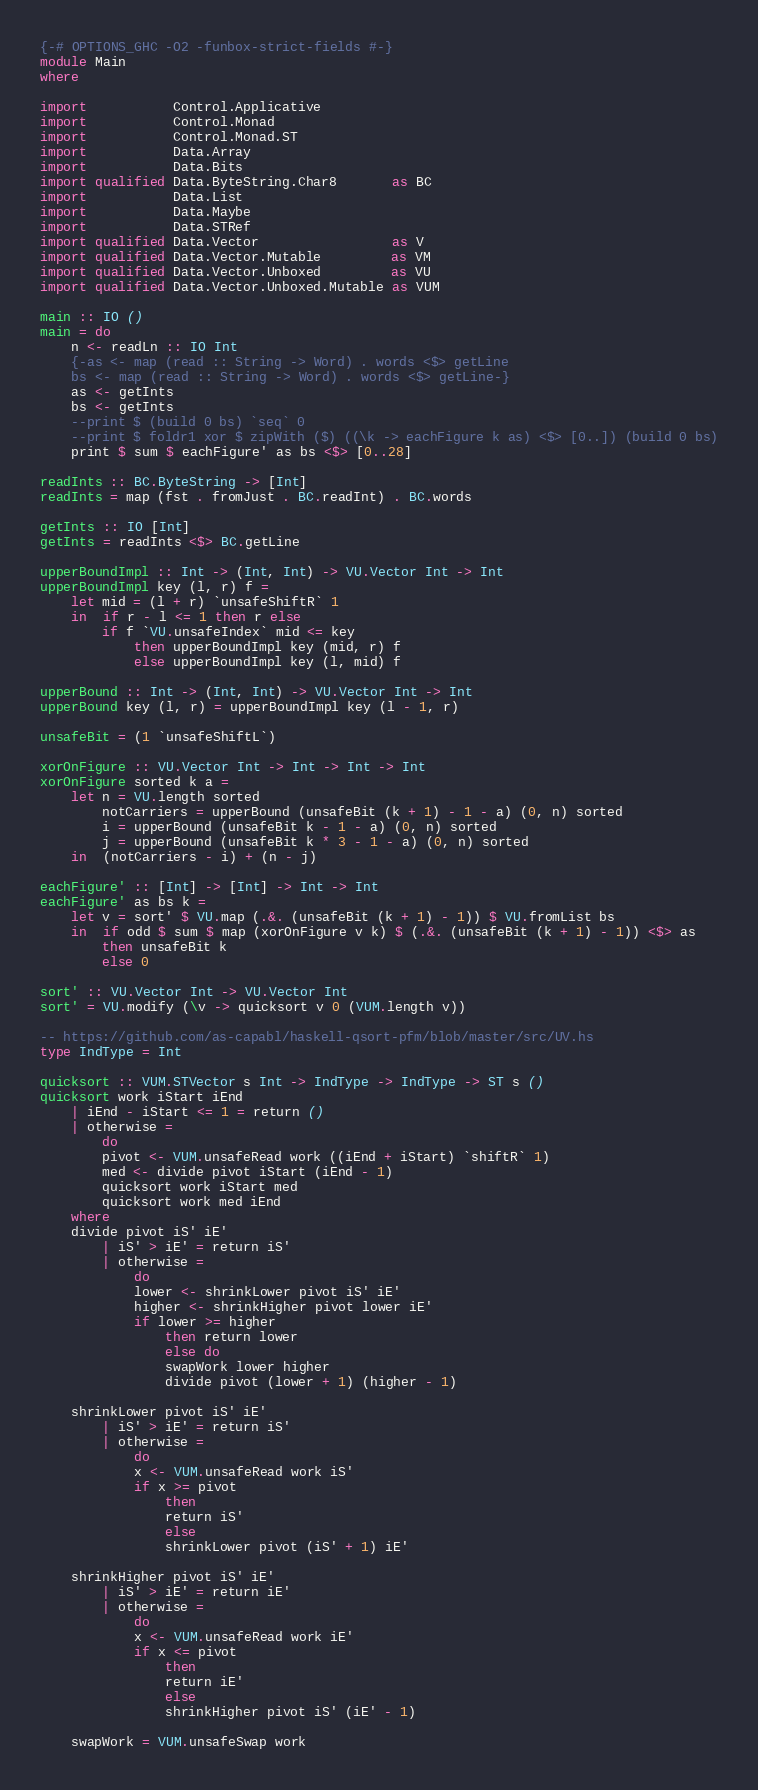<code> <loc_0><loc_0><loc_500><loc_500><_Haskell_>{-# OPTIONS_GHC -O2 -funbox-strict-fields #-}
module Main
where

import           Control.Applicative
import           Control.Monad
import           Control.Monad.ST
import           Data.Array
import           Data.Bits
import qualified Data.ByteString.Char8       as BC
import           Data.List
import           Data.Maybe
import           Data.STRef
import qualified Data.Vector                 as V
import qualified Data.Vector.Mutable         as VM
import qualified Data.Vector.Unboxed         as VU
import qualified Data.Vector.Unboxed.Mutable as VUM

main :: IO ()
main = do
    n <- readLn :: IO Int
    {-as <- map (read :: String -> Word) . words <$> getLine
    bs <- map (read :: String -> Word) . words <$> getLine-}
    as <- getInts
    bs <- getInts
    --print $ (build 0 bs) `seq` 0
    --print $ foldr1 xor $ zipWith ($) ((\k -> eachFigure k as) <$> [0..]) (build 0 bs)
    print $ sum $ eachFigure' as bs <$> [0..28]

readInts :: BC.ByteString -> [Int]
readInts = map (fst . fromJust . BC.readInt) . BC.words

getInts :: IO [Int]
getInts = readInts <$> BC.getLine

upperBoundImpl :: Int -> (Int, Int) -> VU.Vector Int -> Int
upperBoundImpl key (l, r) f =
    let mid = (l + r) `unsafeShiftR` 1
    in  if r - l <= 1 then r else
        if f `VU.unsafeIndex` mid <= key
            then upperBoundImpl key (mid, r) f
            else upperBoundImpl key (l, mid) f

upperBound :: Int -> (Int, Int) -> VU.Vector Int -> Int
upperBound key (l, r) = upperBoundImpl key (l - 1, r)

unsafeBit = (1 `unsafeShiftL`)

xorOnFigure :: VU.Vector Int -> Int -> Int -> Int
xorOnFigure sorted k a =
    let n = VU.length sorted
        notCarriers = upperBound (unsafeBit (k + 1) - 1 - a) (0, n) sorted
        i = upperBound (unsafeBit k - 1 - a) (0, n) sorted
        j = upperBound (unsafeBit k * 3 - 1 - a) (0, n) sorted
    in  (notCarriers - i) + (n - j)

eachFigure' :: [Int] -> [Int] -> Int -> Int
eachFigure' as bs k =
    let v = sort' $ VU.map (.&. (unsafeBit (k + 1) - 1)) $ VU.fromList bs
    in  if odd $ sum $ map (xorOnFigure v k) $ (.&. (unsafeBit (k + 1) - 1)) <$> as
        then unsafeBit k
        else 0

sort' :: VU.Vector Int -> VU.Vector Int
sort' = VU.modify (\v -> quicksort v 0 (VUM.length v))

-- https://github.com/as-capabl/haskell-qsort-pfm/blob/master/src/UV.hs
type IndType = Int

quicksort :: VUM.STVector s Int -> IndType -> IndType -> ST s ()
quicksort work iStart iEnd
    | iEnd - iStart <= 1 = return ()
    | otherwise =
        do
        pivot <- VUM.unsafeRead work ((iEnd + iStart) `shiftR` 1)
        med <- divide pivot iStart (iEnd - 1)
        quicksort work iStart med
        quicksort work med iEnd
    where
    divide pivot iS' iE'
        | iS' > iE' = return iS'
        | otherwise =
            do
            lower <- shrinkLower pivot iS' iE'
            higher <- shrinkHigher pivot lower iE'
            if lower >= higher
                then return lower
                else do
                swapWork lower higher
                divide pivot (lower + 1) (higher - 1)

    shrinkLower pivot iS' iE'
        | iS' > iE' = return iS'
        | otherwise =
            do
            x <- VUM.unsafeRead work iS'
            if x >= pivot
                then
                return iS'
                else
                shrinkLower pivot (iS' + 1) iE'

    shrinkHigher pivot iS' iE'
        | iS' > iE' = return iE'
        | otherwise =
            do
            x <- VUM.unsafeRead work iE'
            if x <= pivot
                then
                return iE'
                else
                shrinkHigher pivot iS' (iE' - 1)

    swapWork = VUM.unsafeSwap work
</code> 